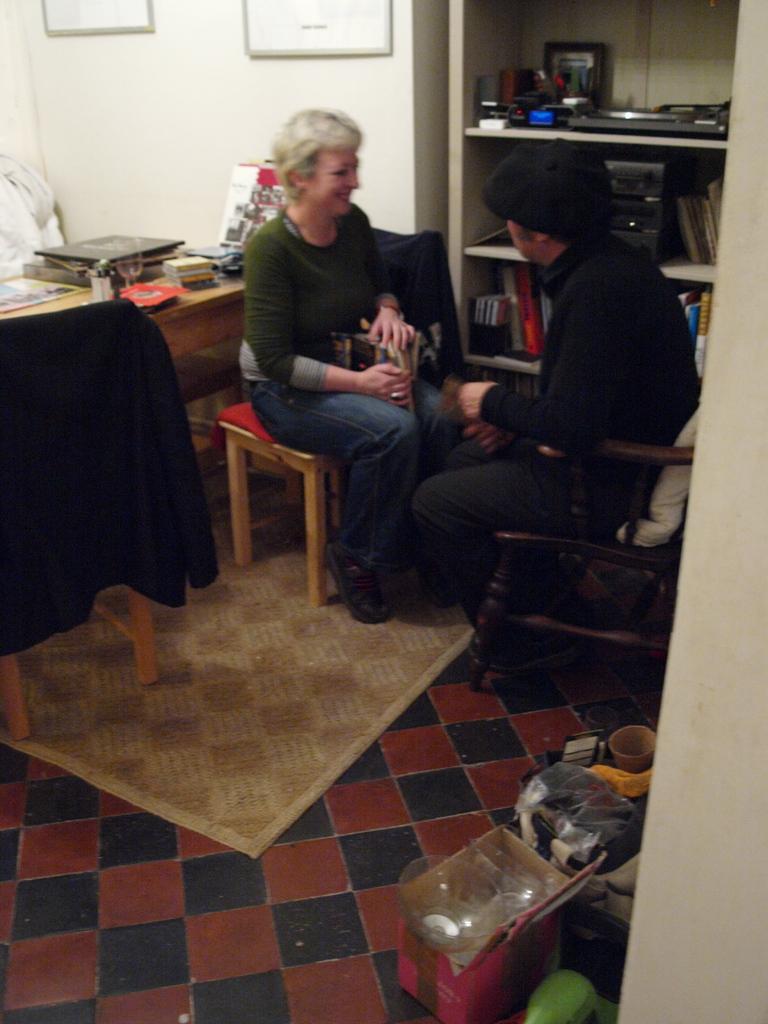Describe this image in one or two sentences. In the background we can see frames on the wall. We can see objects and books in the racks. We can see people sitting on the chairs. On the floor we can see floor carpet, boxes and few other objects. On the left side we can see a laptop and few objects on the floor. On the chair we can see a black jacket. 